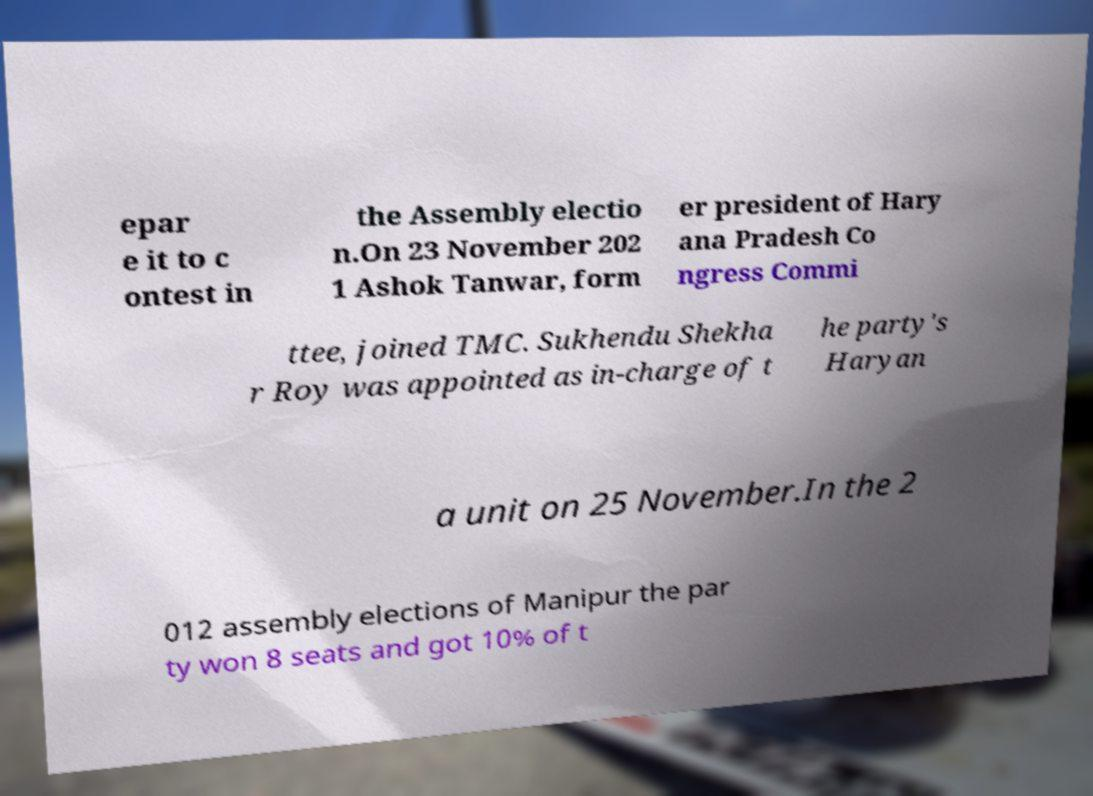Can you read and provide the text displayed in the image?This photo seems to have some interesting text. Can you extract and type it out for me? epar e it to c ontest in the Assembly electio n.On 23 November 202 1 Ashok Tanwar, form er president of Hary ana Pradesh Co ngress Commi ttee, joined TMC. Sukhendu Shekha r Roy was appointed as in-charge of t he party's Haryan a unit on 25 November.In the 2 012 assembly elections of Manipur the par ty won 8 seats and got 10% of t 